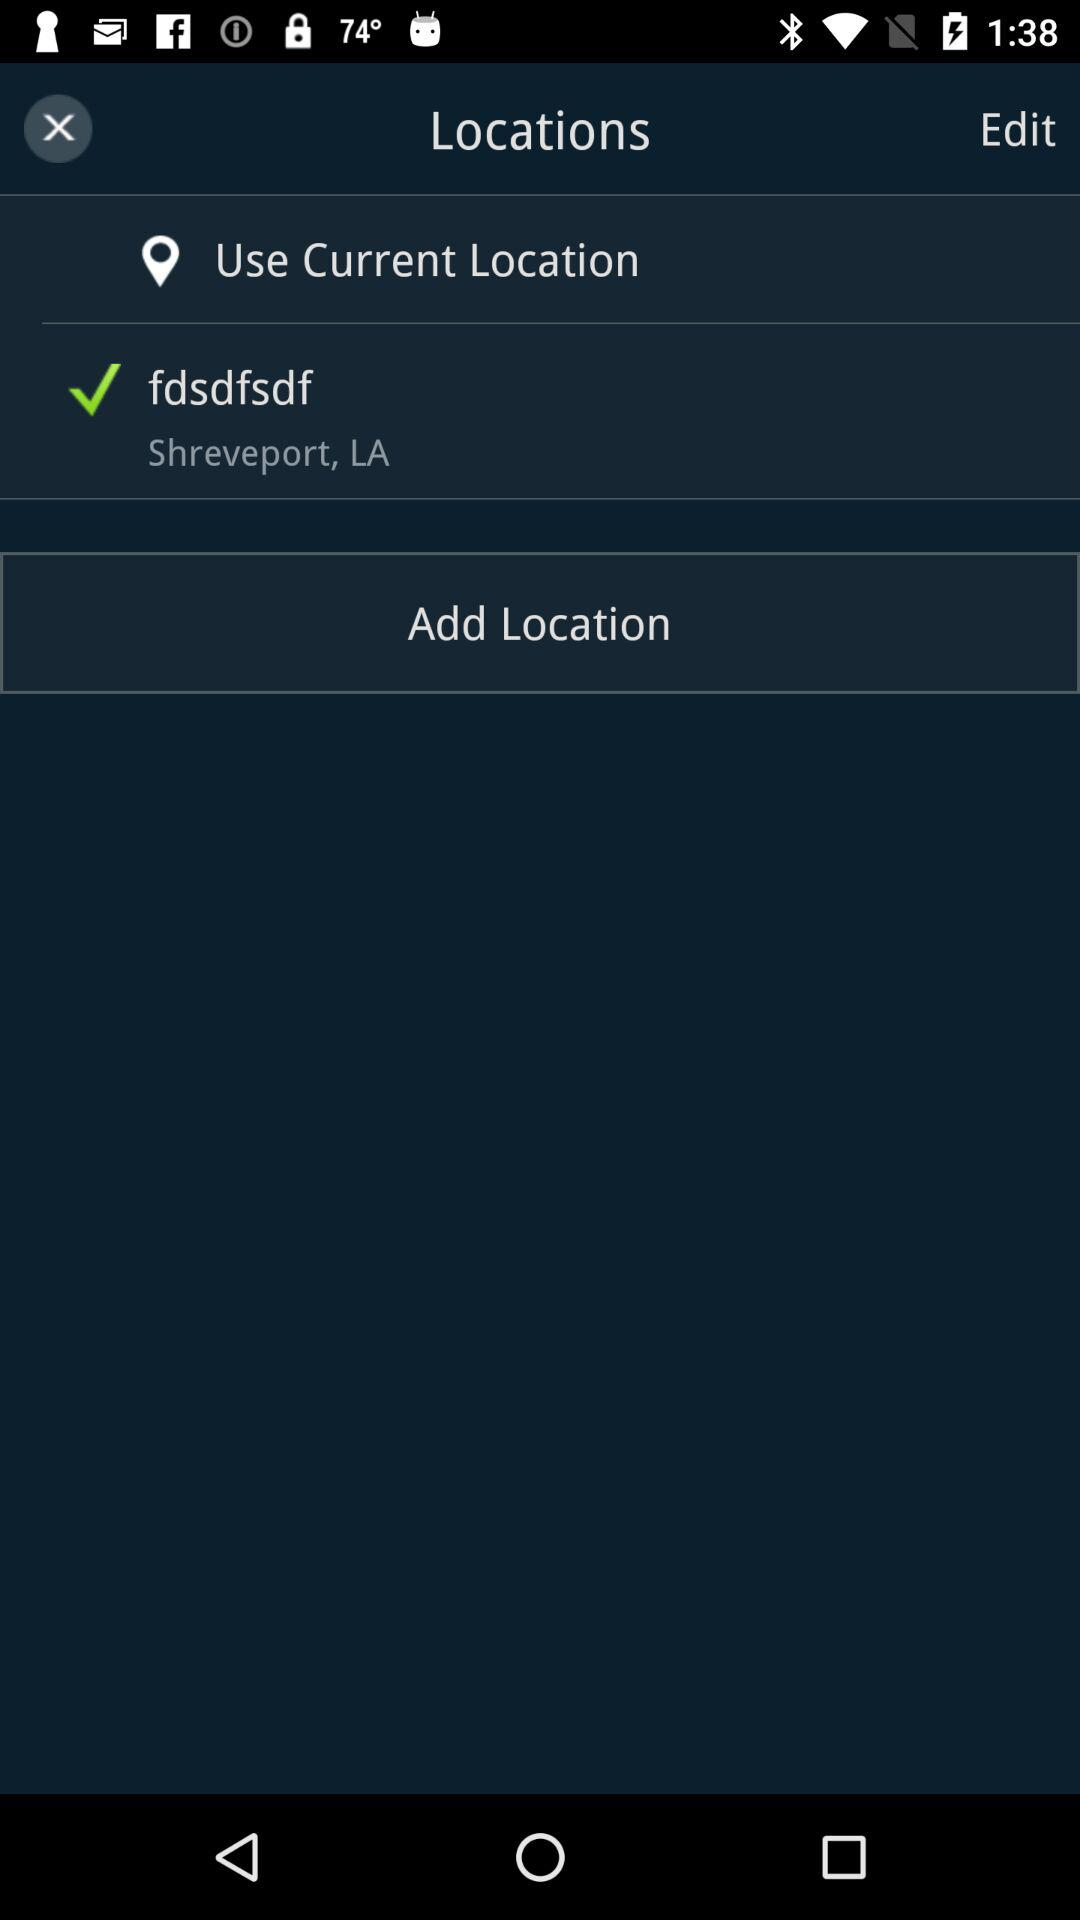What is the current location? The current location is fdsdfsdf, Shreveport, LA. 